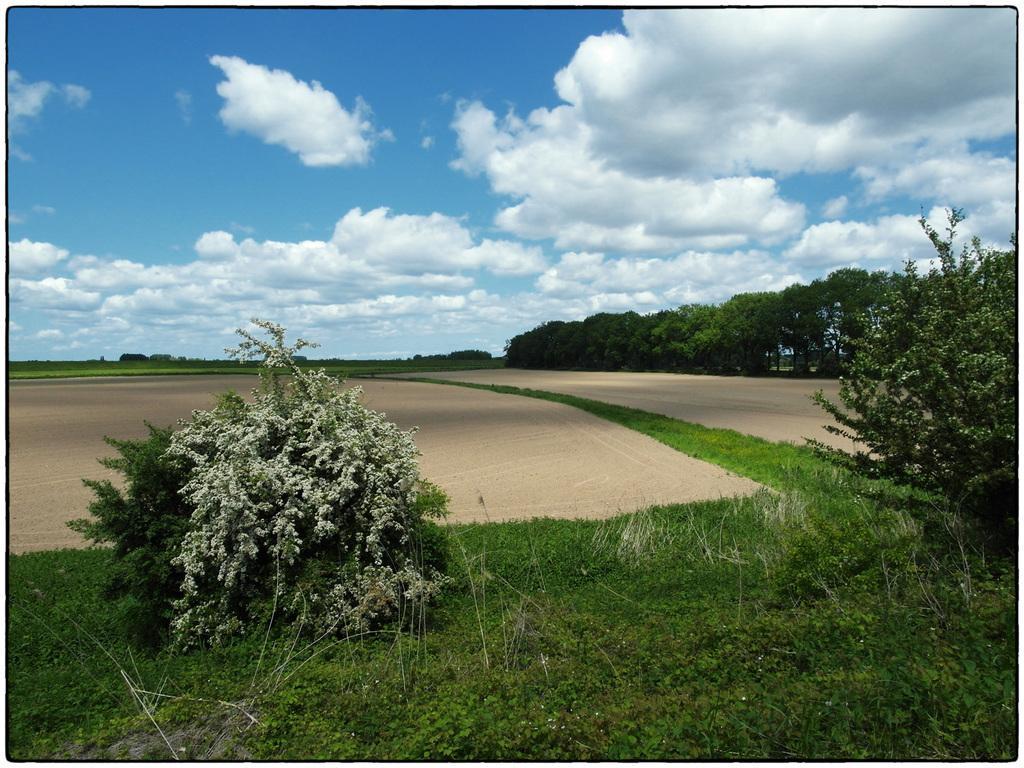Could you give a brief overview of what you see in this image? There are plants and grassland in the foreground area of the image, there are trees, it seems like a road and the sky in the background. 